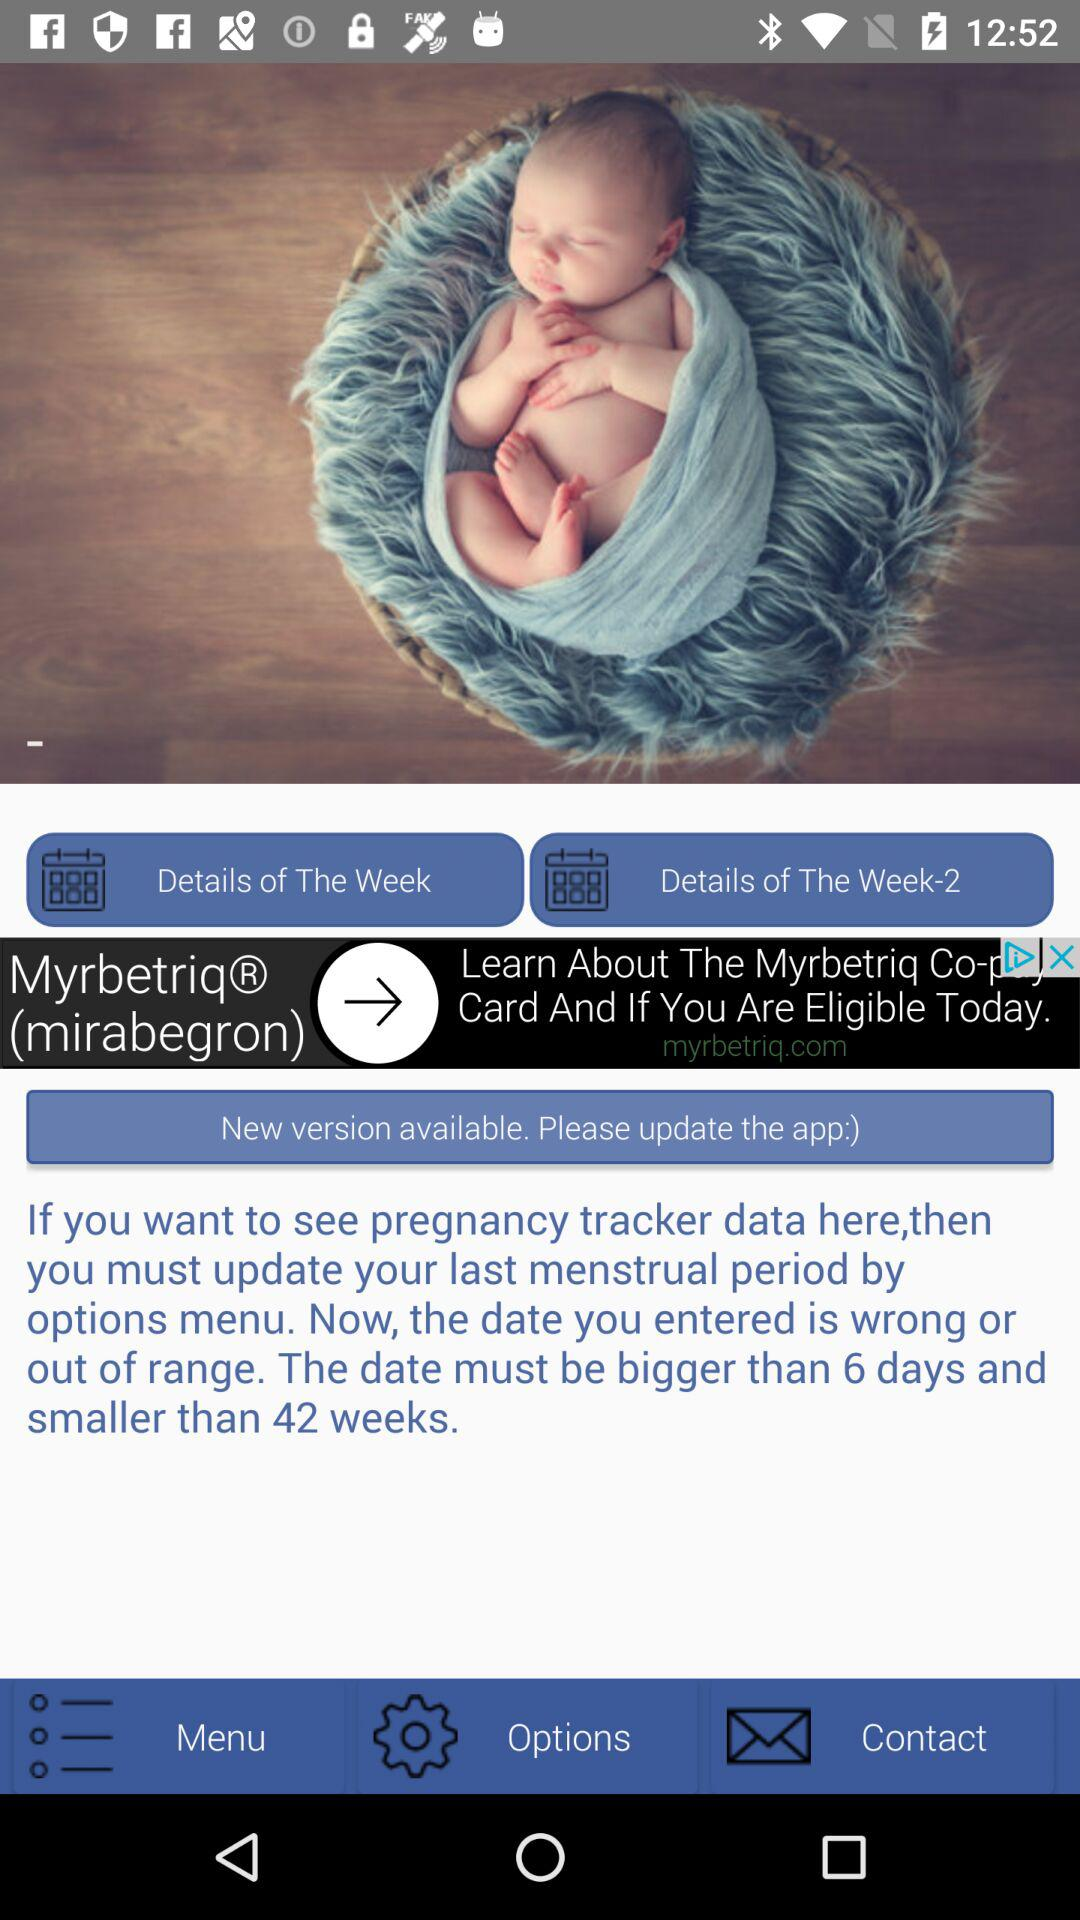What is the number of weeks? The number of weeks is 42. 